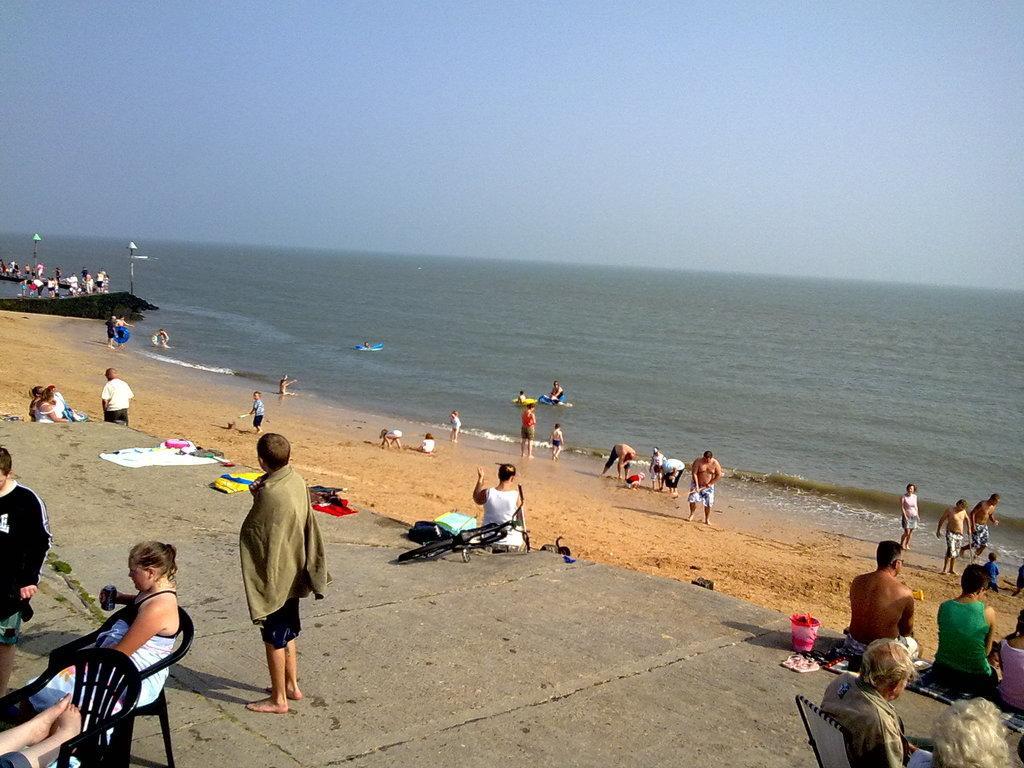Please provide a concise description of this image. In this image it looks like a beach in which there are few people who are swimming in the water while other are playing in the sand. On the left side there are few people sitting on the chairs. At the top there is the sky. On the right side bottom there are few people sitting on the floor. 